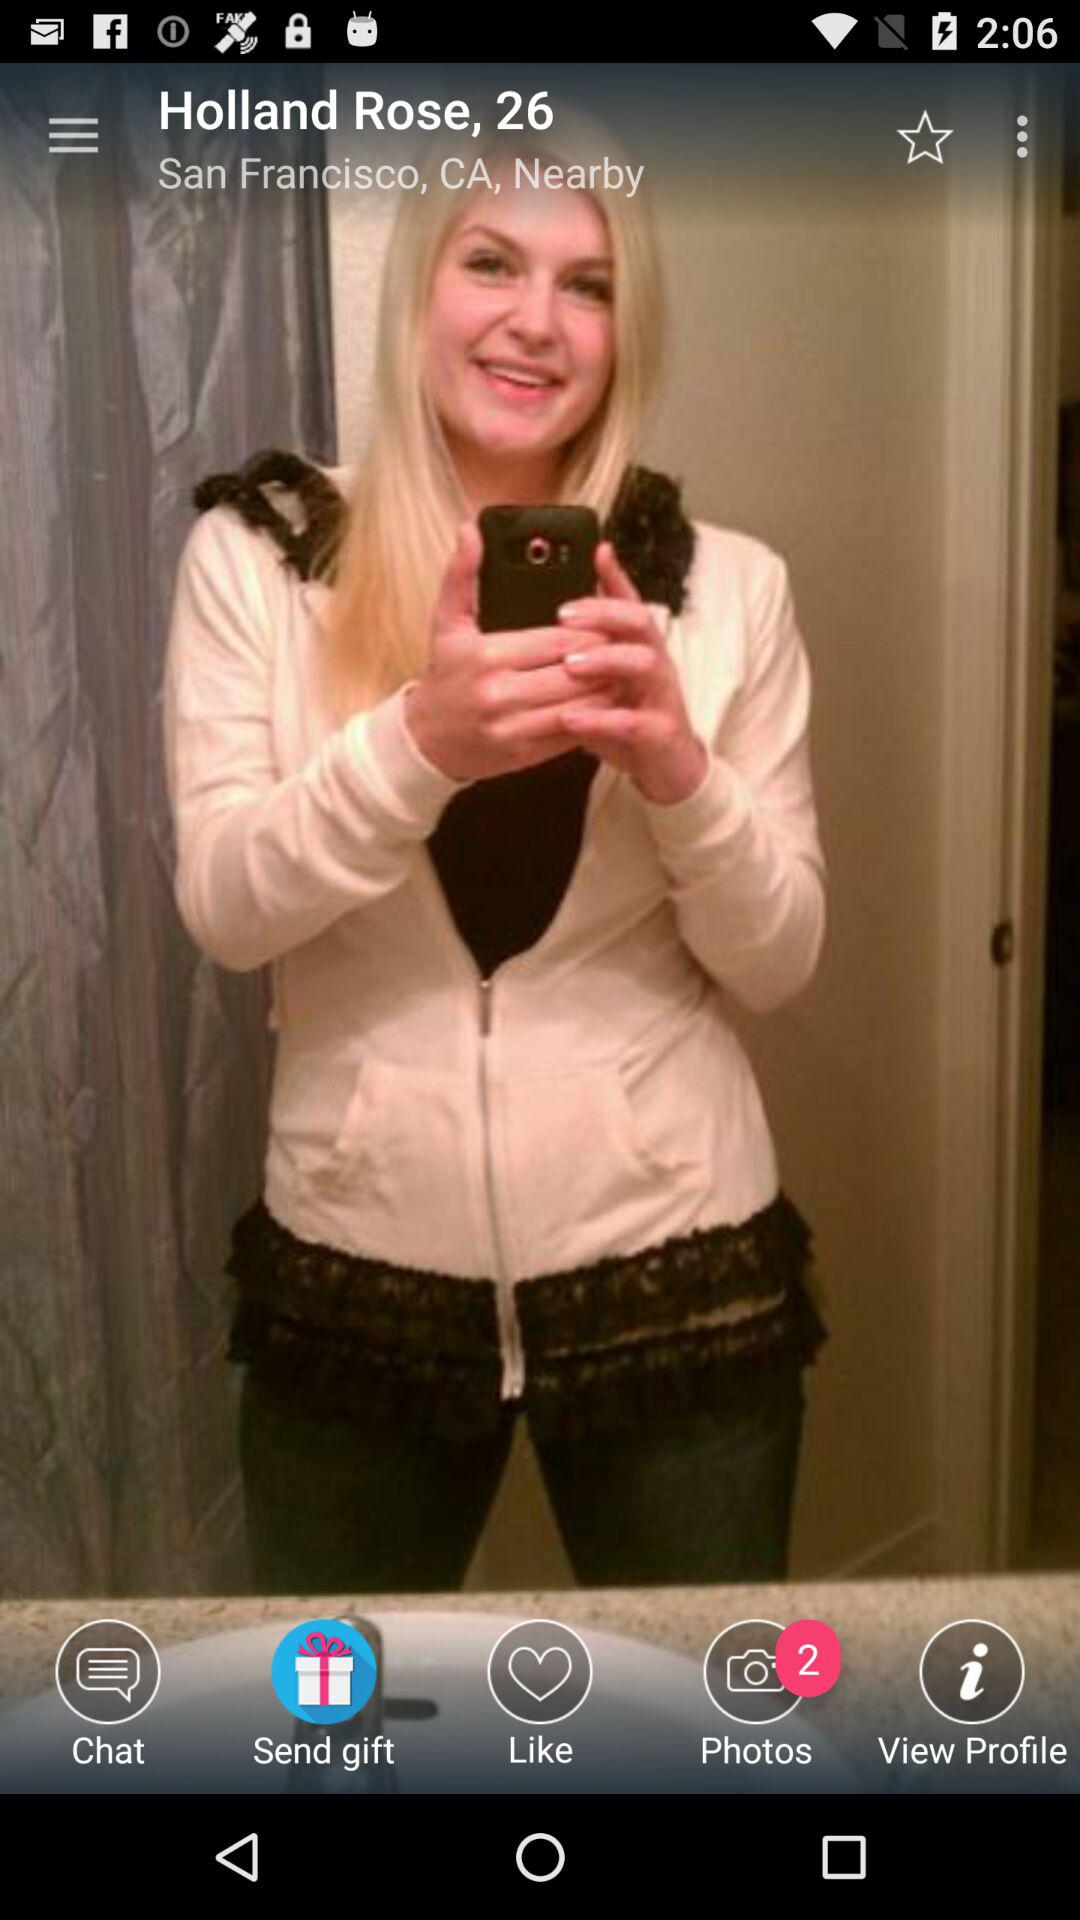What is the selected option? The selected option is "Send gift". 